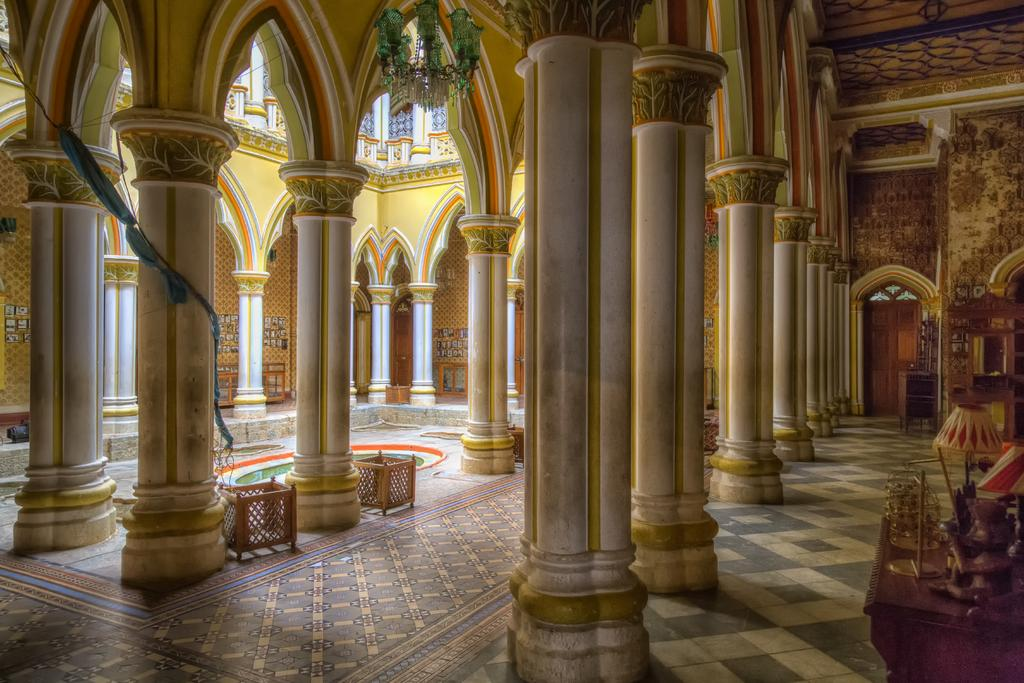What type of setting is depicted in the image? The image shows the interior of a house. Are there any specific objects visible on a surface in the image? Yes, there are objects placed on a wooden table in the image. How many guitars can be seen floating in the basin in the image? There are no guitars or basins present in the image. What type of boats are visible in the image? There are no boats present in the image. 